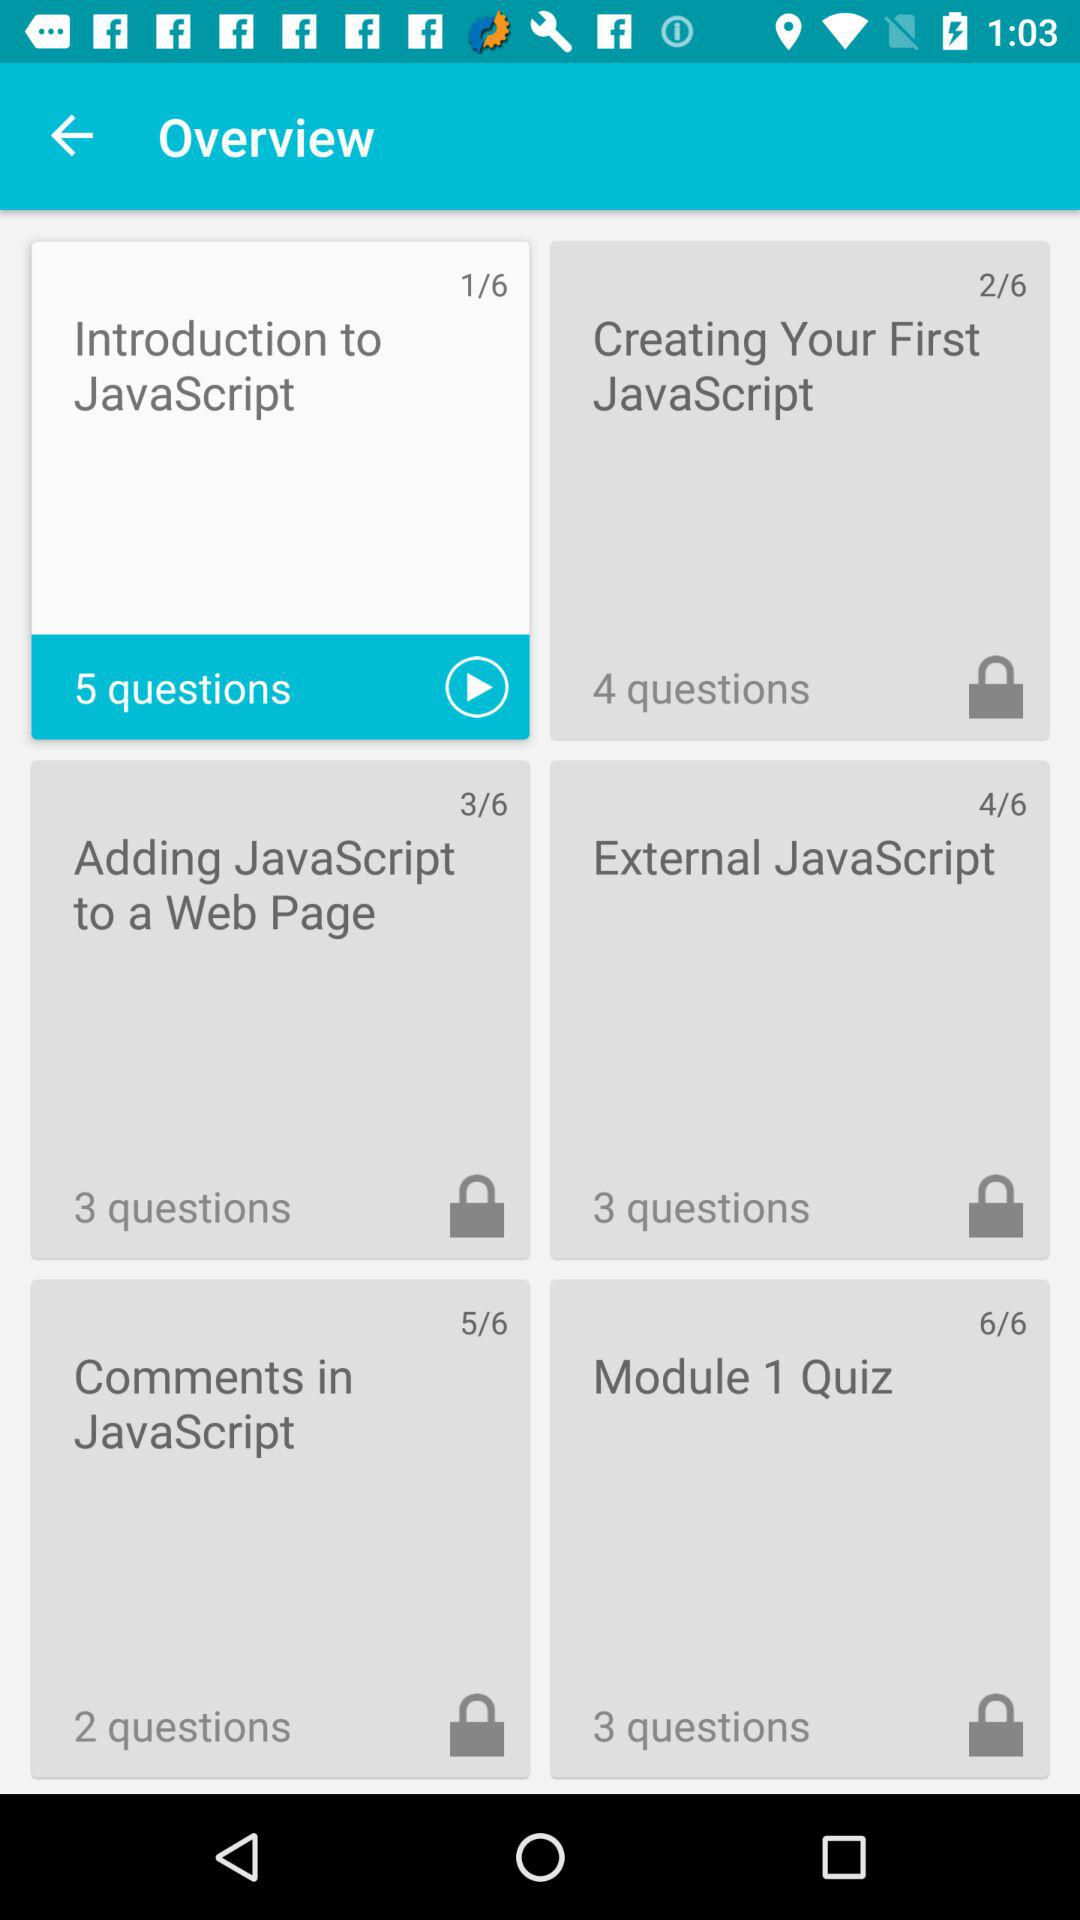How many topics are covered in this module?
Answer the question using a single word or phrase. 6 